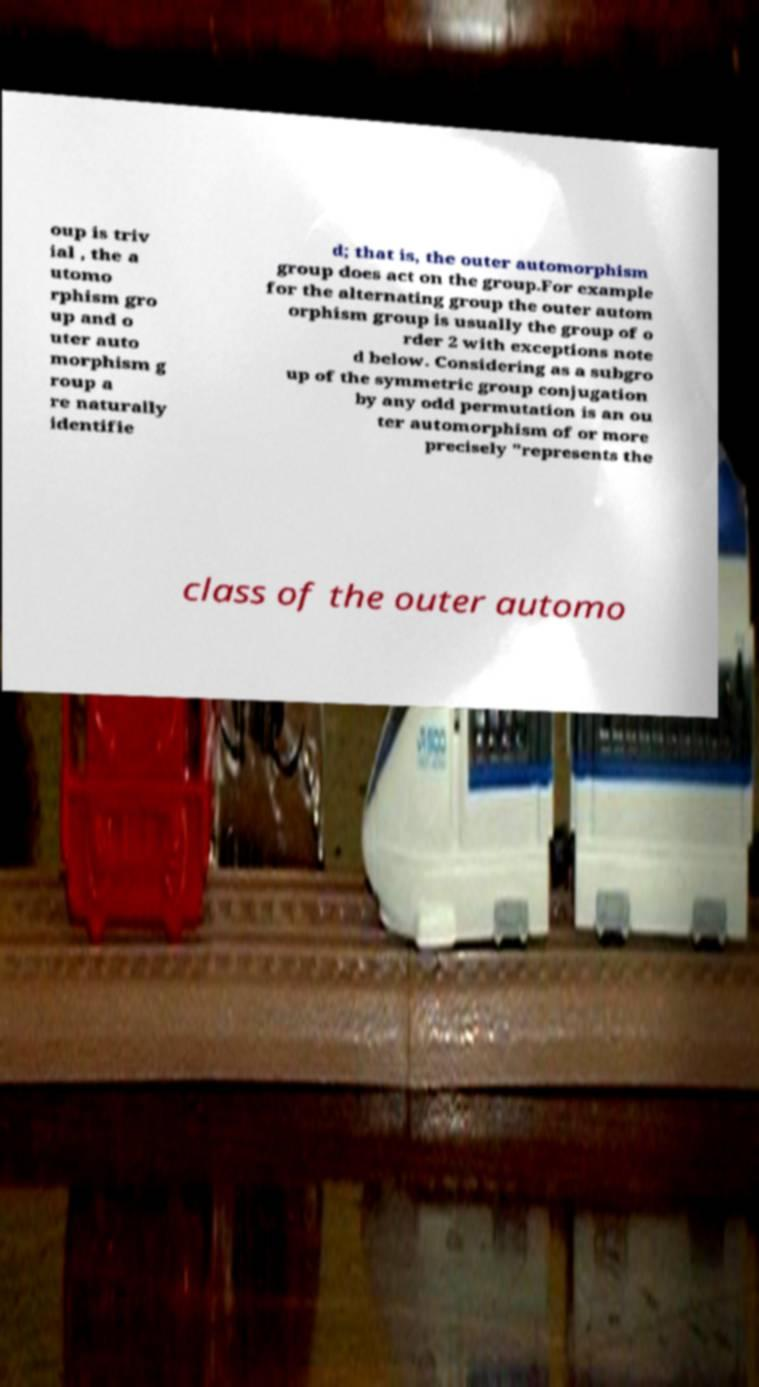What messages or text are displayed in this image? I need them in a readable, typed format. oup is triv ial , the a utomo rphism gro up and o uter auto morphism g roup a re naturally identifie d; that is, the outer automorphism group does act on the group.For example for the alternating group the outer autom orphism group is usually the group of o rder 2 with exceptions note d below. Considering as a subgro up of the symmetric group conjugation by any odd permutation is an ou ter automorphism of or more precisely "represents the class of the outer automo 